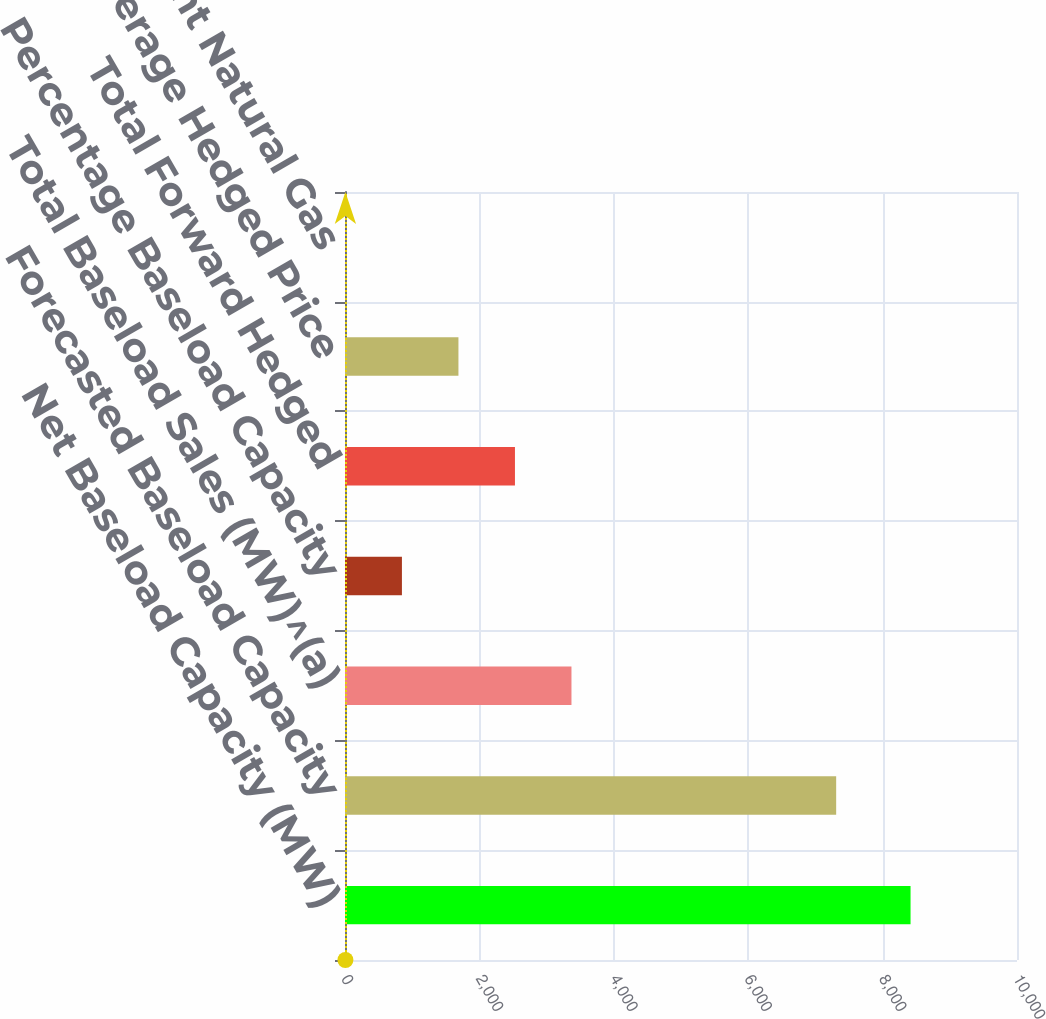Convert chart. <chart><loc_0><loc_0><loc_500><loc_500><bar_chart><fcel>Net Baseload Capacity (MW)<fcel>Forecasted Baseload Capacity<fcel>Total Baseload Sales (MW)^(a)<fcel>Percentage Baseload Capacity<fcel>Total Forward Hedged<fcel>Weighted Average Hedged Price<fcel>Average Equivalent Natural Gas<nl><fcel>8416<fcel>7309<fcel>3370.06<fcel>847.09<fcel>2529.07<fcel>1688.08<fcel>6.1<nl></chart> 